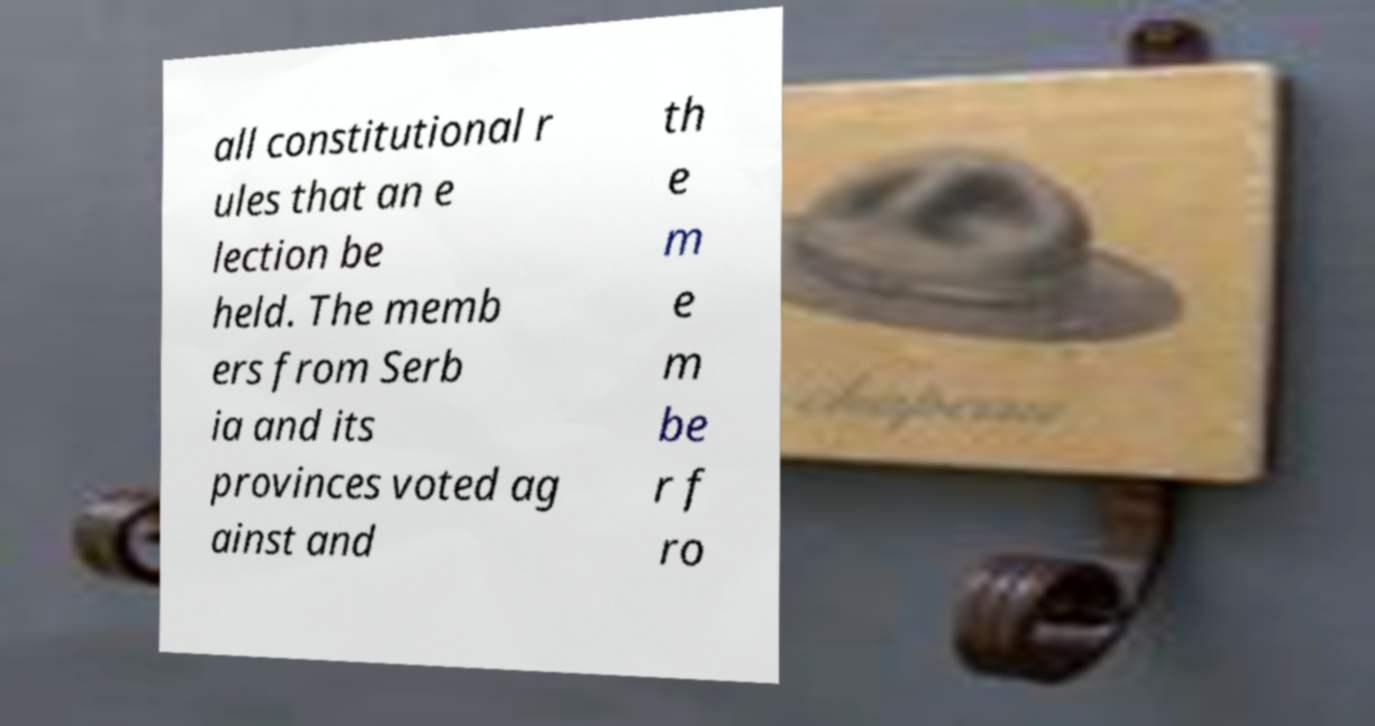Could you extract and type out the text from this image? all constitutional r ules that an e lection be held. The memb ers from Serb ia and its provinces voted ag ainst and th e m e m be r f ro 